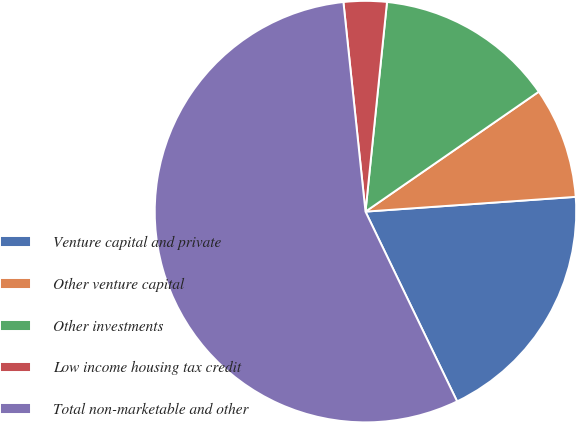Convert chart. <chart><loc_0><loc_0><loc_500><loc_500><pie_chart><fcel>Venture capital and private<fcel>Other venture capital<fcel>Other investments<fcel>Low income housing tax credit<fcel>Total non-marketable and other<nl><fcel>18.96%<fcel>8.52%<fcel>13.74%<fcel>3.3%<fcel>55.5%<nl></chart> 